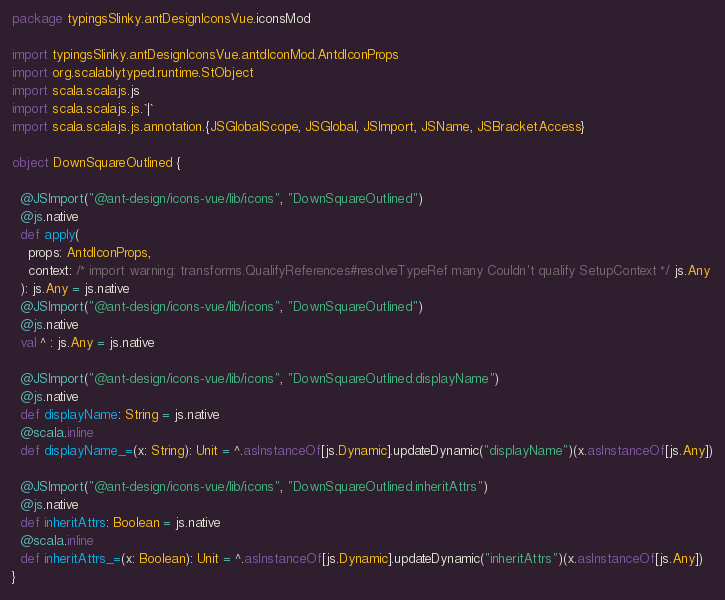Convert code to text. <code><loc_0><loc_0><loc_500><loc_500><_Scala_>package typingsSlinky.antDesignIconsVue.iconsMod

import typingsSlinky.antDesignIconsVue.antdIconMod.AntdIconProps
import org.scalablytyped.runtime.StObject
import scala.scalajs.js
import scala.scalajs.js.`|`
import scala.scalajs.js.annotation.{JSGlobalScope, JSGlobal, JSImport, JSName, JSBracketAccess}

object DownSquareOutlined {
  
  @JSImport("@ant-design/icons-vue/lib/icons", "DownSquareOutlined")
  @js.native
  def apply(
    props: AntdIconProps,
    context: /* import warning: transforms.QualifyReferences#resolveTypeRef many Couldn't qualify SetupContext */ js.Any
  ): js.Any = js.native
  @JSImport("@ant-design/icons-vue/lib/icons", "DownSquareOutlined")
  @js.native
  val ^ : js.Any = js.native
  
  @JSImport("@ant-design/icons-vue/lib/icons", "DownSquareOutlined.displayName")
  @js.native
  def displayName: String = js.native
  @scala.inline
  def displayName_=(x: String): Unit = ^.asInstanceOf[js.Dynamic].updateDynamic("displayName")(x.asInstanceOf[js.Any])
  
  @JSImport("@ant-design/icons-vue/lib/icons", "DownSquareOutlined.inheritAttrs")
  @js.native
  def inheritAttrs: Boolean = js.native
  @scala.inline
  def inheritAttrs_=(x: Boolean): Unit = ^.asInstanceOf[js.Dynamic].updateDynamic("inheritAttrs")(x.asInstanceOf[js.Any])
}
</code> 